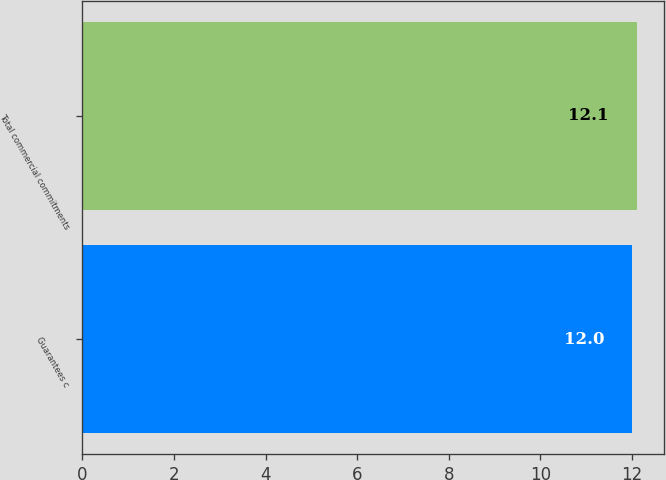<chart> <loc_0><loc_0><loc_500><loc_500><bar_chart><fcel>Guarantees c<fcel>Total commercial commitments<nl><fcel>12<fcel>12.1<nl></chart> 